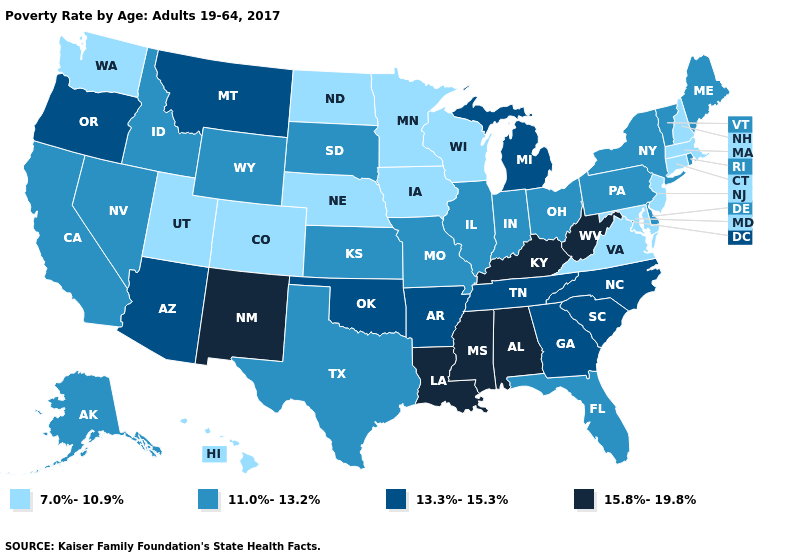What is the highest value in states that border New Mexico?
Be succinct. 13.3%-15.3%. What is the highest value in the MidWest ?
Concise answer only. 13.3%-15.3%. Name the states that have a value in the range 7.0%-10.9%?
Quick response, please. Colorado, Connecticut, Hawaii, Iowa, Maryland, Massachusetts, Minnesota, Nebraska, New Hampshire, New Jersey, North Dakota, Utah, Virginia, Washington, Wisconsin. Does Virginia have the lowest value in the South?
Answer briefly. Yes. Which states have the lowest value in the USA?
Quick response, please. Colorado, Connecticut, Hawaii, Iowa, Maryland, Massachusetts, Minnesota, Nebraska, New Hampshire, New Jersey, North Dakota, Utah, Virginia, Washington, Wisconsin. Name the states that have a value in the range 7.0%-10.9%?
Quick response, please. Colorado, Connecticut, Hawaii, Iowa, Maryland, Massachusetts, Minnesota, Nebraska, New Hampshire, New Jersey, North Dakota, Utah, Virginia, Washington, Wisconsin. Name the states that have a value in the range 11.0%-13.2%?
Concise answer only. Alaska, California, Delaware, Florida, Idaho, Illinois, Indiana, Kansas, Maine, Missouri, Nevada, New York, Ohio, Pennsylvania, Rhode Island, South Dakota, Texas, Vermont, Wyoming. Does New Mexico have the same value as Iowa?
Keep it brief. No. Name the states that have a value in the range 11.0%-13.2%?
Concise answer only. Alaska, California, Delaware, Florida, Idaho, Illinois, Indiana, Kansas, Maine, Missouri, Nevada, New York, Ohio, Pennsylvania, Rhode Island, South Dakota, Texas, Vermont, Wyoming. How many symbols are there in the legend?
Keep it brief. 4. What is the value of North Carolina?
Keep it brief. 13.3%-15.3%. Does the first symbol in the legend represent the smallest category?
Quick response, please. Yes. What is the value of North Carolina?
Short answer required. 13.3%-15.3%. Does Connecticut have the lowest value in the USA?
Answer briefly. Yes. Does the first symbol in the legend represent the smallest category?
Concise answer only. Yes. 